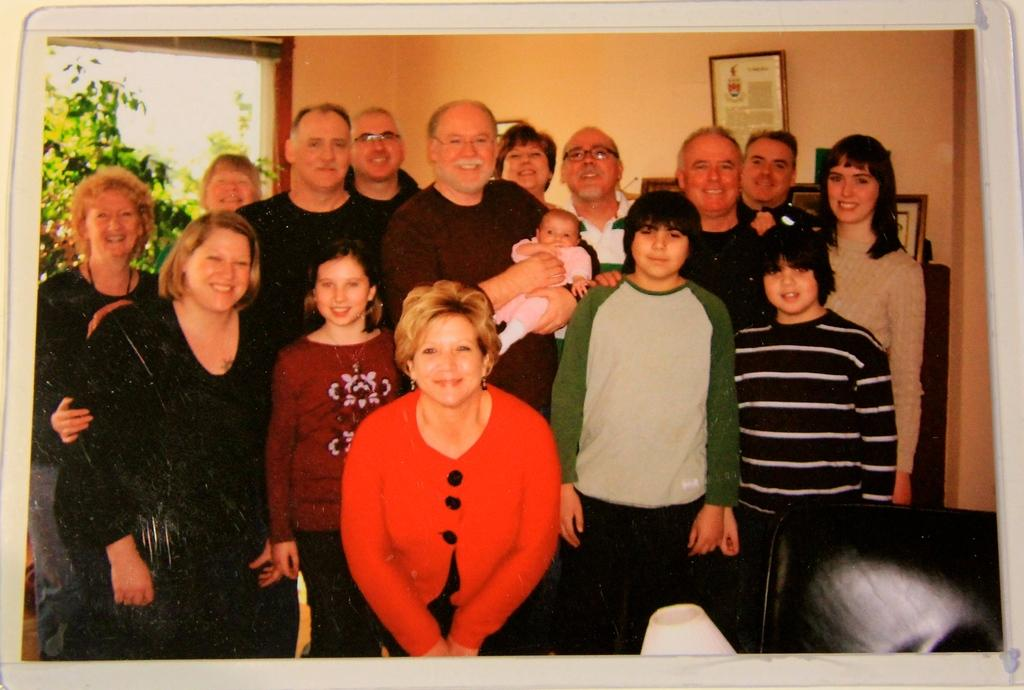How many people are in the image? There are many people in the image. What expressions do the people have? The people are smiling. What can be seen in the background of the image? There is a wall with a frame and a window in the background. What is visible through the window? Trees are visible through the window. What type of hot man can be seen holding a plate in the image? There is no man, hot or otherwise, holding a plate in the image. The image features a group of people smiling, and there is no mention of a plate or a hot man. 